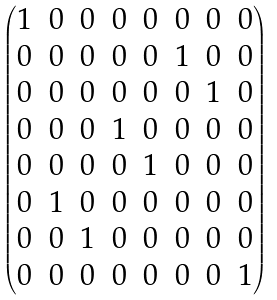Convert formula to latex. <formula><loc_0><loc_0><loc_500><loc_500>\begin{pmatrix} 1 & 0 & 0 & 0 & 0 & 0 & 0 & 0 \\ 0 & 0 & 0 & 0 & 0 & 1 & 0 & 0 \\ 0 & 0 & 0 & 0 & 0 & 0 & 1 & 0 \\ 0 & 0 & 0 & 1 & 0 & 0 & 0 & 0 \\ 0 & 0 & 0 & 0 & 1 & 0 & 0 & 0 \\ 0 & 1 & 0 & 0 & 0 & 0 & 0 & 0 \\ 0 & 0 & 1 & 0 & 0 & 0 & 0 & 0 \\ 0 & 0 & 0 & 0 & 0 & 0 & 0 & 1 \end{pmatrix}</formula> 